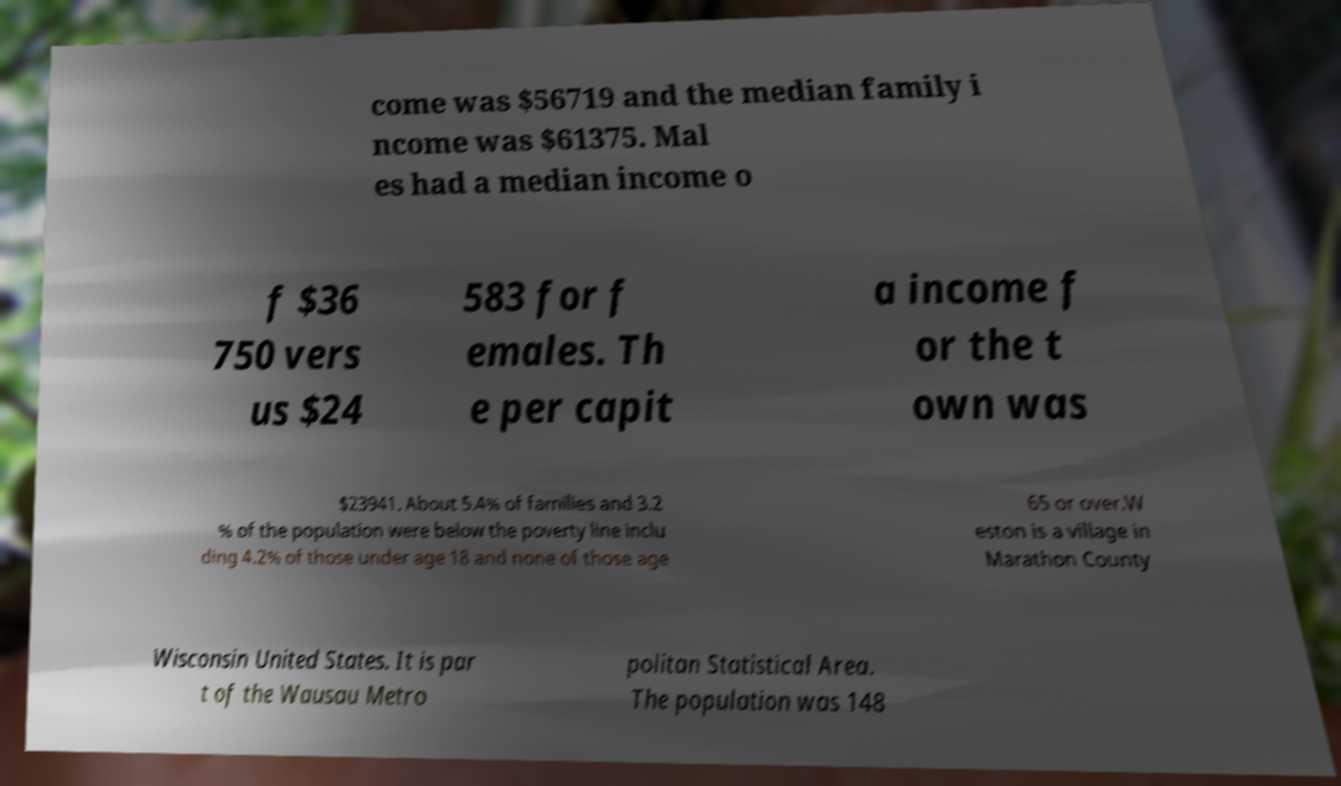For documentation purposes, I need the text within this image transcribed. Could you provide that? come was $56719 and the median family i ncome was $61375. Mal es had a median income o f $36 750 vers us $24 583 for f emales. Th e per capit a income f or the t own was $23941. About 5.4% of families and 3.2 % of the population were below the poverty line inclu ding 4.2% of those under age 18 and none of those age 65 or over.W eston is a village in Marathon County Wisconsin United States. It is par t of the Wausau Metro politan Statistical Area. The population was 148 